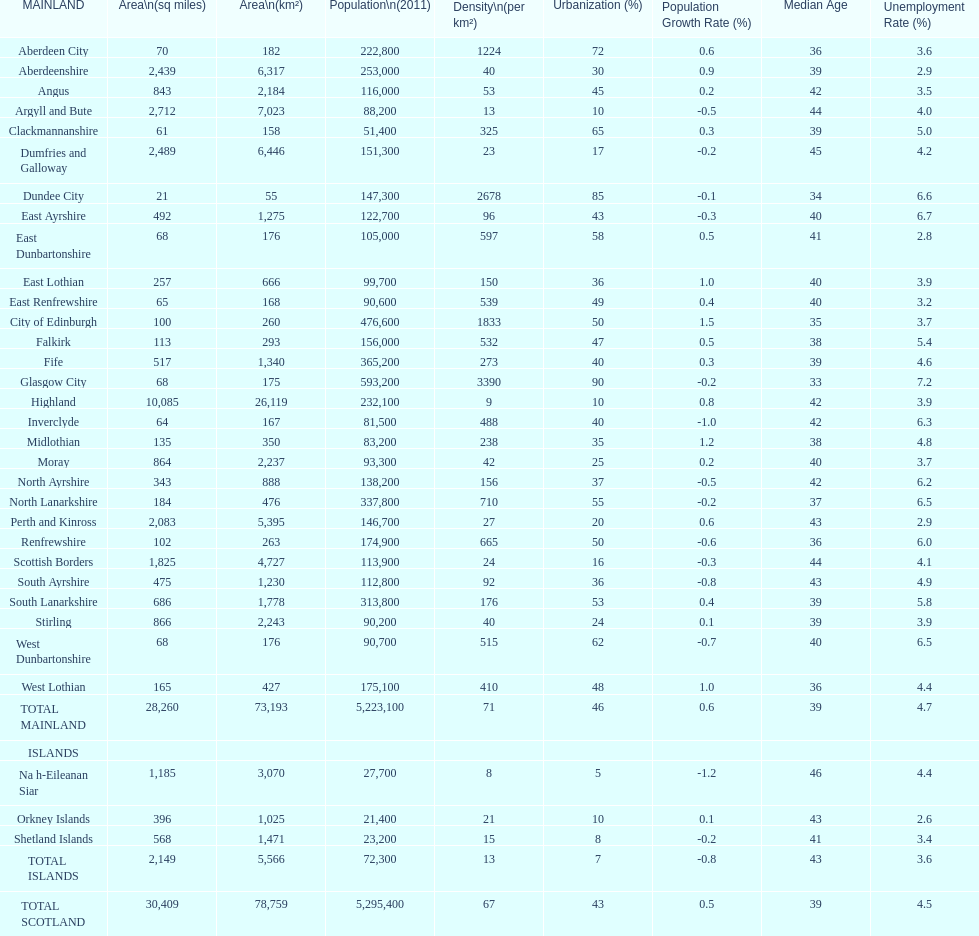What is the number of people living in angus in 2011? 116,000. Help me parse the entirety of this table. {'header': ['MAINLAND', 'Area\\n(sq miles)', 'Area\\n(km²)', 'Population\\n(2011)', 'Density\\n(per km²)', 'Urbanization (%)', 'Population Growth Rate (%)', 'Median Age', 'Unemployment Rate (%)'], 'rows': [['Aberdeen City', '70', '182', '222,800', '1224', '72', '0.6', '36', '3.6'], ['Aberdeenshire', '2,439', '6,317', '253,000', '40', '30', '0.9', '39', '2.9'], ['Angus', '843', '2,184', '116,000', '53', '45', '0.2', '42', '3.5'], ['Argyll and Bute', '2,712', '7,023', '88,200', '13', '10', '-0.5', '44', '4.0'], ['Clackmannanshire', '61', '158', '51,400', '325', '65', '0.3', '39', '5.0'], ['Dumfries and Galloway', '2,489', '6,446', '151,300', '23', '17', '-0.2', '45', '4.2'], ['Dundee City', '21', '55', '147,300', '2678', '85', '-0.1', '34', '6.6'], ['East Ayrshire', '492', '1,275', '122,700', '96', '43', '-0.3', '40', '6.7'], ['East Dunbartonshire', '68', '176', '105,000', '597', '58', '0.5', '41', '2.8'], ['East Lothian', '257', '666', '99,700', '150', '36', '1.0', '40', '3.9'], ['East Renfrewshire', '65', '168', '90,600', '539', '49', '0.4', '40', '3.2'], ['City of Edinburgh', '100', '260', '476,600', '1833', '50', '1.5', '35', '3.7'], ['Falkirk', '113', '293', '156,000', '532', '47', '0.5', '38', '5.4'], ['Fife', '517', '1,340', '365,200', '273', '40', '0.3', '39', '4.6'], ['Glasgow City', '68', '175', '593,200', '3390', '90', '-0.2', '33', '7.2'], ['Highland', '10,085', '26,119', '232,100', '9', '10', '0.8', '42', '3.9'], ['Inverclyde', '64', '167', '81,500', '488', '40', '-1.0', '42', '6.3'], ['Midlothian', '135', '350', '83,200', '238', '35', '1.2', '38', '4.8'], ['Moray', '864', '2,237', '93,300', '42', '25', '0.2', '40', '3.7'], ['North Ayrshire', '343', '888', '138,200', '156', '37', '-0.5', '42', '6.2'], ['North Lanarkshire', '184', '476', '337,800', '710', '55', '-0.2', '37', '6.5'], ['Perth and Kinross', '2,083', '5,395', '146,700', '27', '20', '0.6', '43', '2.9'], ['Renfrewshire', '102', '263', '174,900', '665', '50', '-0.6', '36', '6.0'], ['Scottish Borders', '1,825', '4,727', '113,900', '24', '16', '-0.3', '44', '4.1'], ['South Ayrshire', '475', '1,230', '112,800', '92', '36', '-0.8', '43', '4.9'], ['South Lanarkshire', '686', '1,778', '313,800', '176', '53', '0.4', '39', '5.8'], ['Stirling', '866', '2,243', '90,200', '40', '24', '0.1', '39', '3.9'], ['West Dunbartonshire', '68', '176', '90,700', '515', '62', '-0.7', '40', '6.5'], ['West Lothian', '165', '427', '175,100', '410', '48', '1.0', '36', '4.4'], ['TOTAL MAINLAND', '28,260', '73,193', '5,223,100', '71', '46', '0.6', '39', '4.7'], ['ISLANDS', '', '', '', '', '', '', '', ''], ['Na h-Eileanan Siar', '1,185', '3,070', '27,700', '8', '5', '-1.2', '46', '4.4'], ['Orkney Islands', '396', '1,025', '21,400', '21', '10', '0.1', '43', '2.6'], ['Shetland Islands', '568', '1,471', '23,200', '15', '8', '-0.2', '41', '3.4'], ['TOTAL ISLANDS', '2,149', '5,566', '72,300', '13', '7', '-0.8', '43', '3.6'], ['TOTAL SCOTLAND', '30,409', '78,759', '5,295,400', '67', '43', '0.5', '39', '4.5']]} 